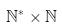<formula> <loc_0><loc_0><loc_500><loc_500>\mathbb { N } ^ { * } \times \mathbb { N }</formula> 